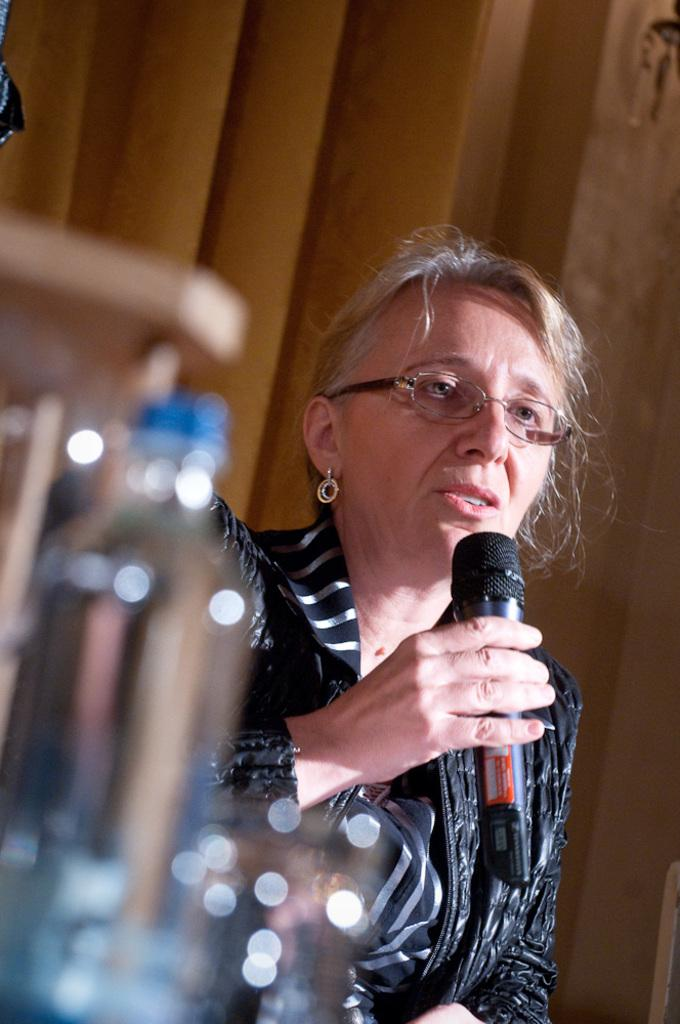Who is the main subject in the image? There is a woman in the image. What is the woman holding in her hand? The woman is holding a mic in her hand. What object is placed in front of the woman? There is a bottle in front of the woman. What can be seen in the background of the image? There is a curtain in the background of the image. What type of lipstick is the woman using in the image? There is no lipstick or any makeup mentioned in the image; the woman is holding a mic. What type of brush is the woman using to paint in the image? There is no brush or painting activity mentioned in the image; the woman is holding a mic. 